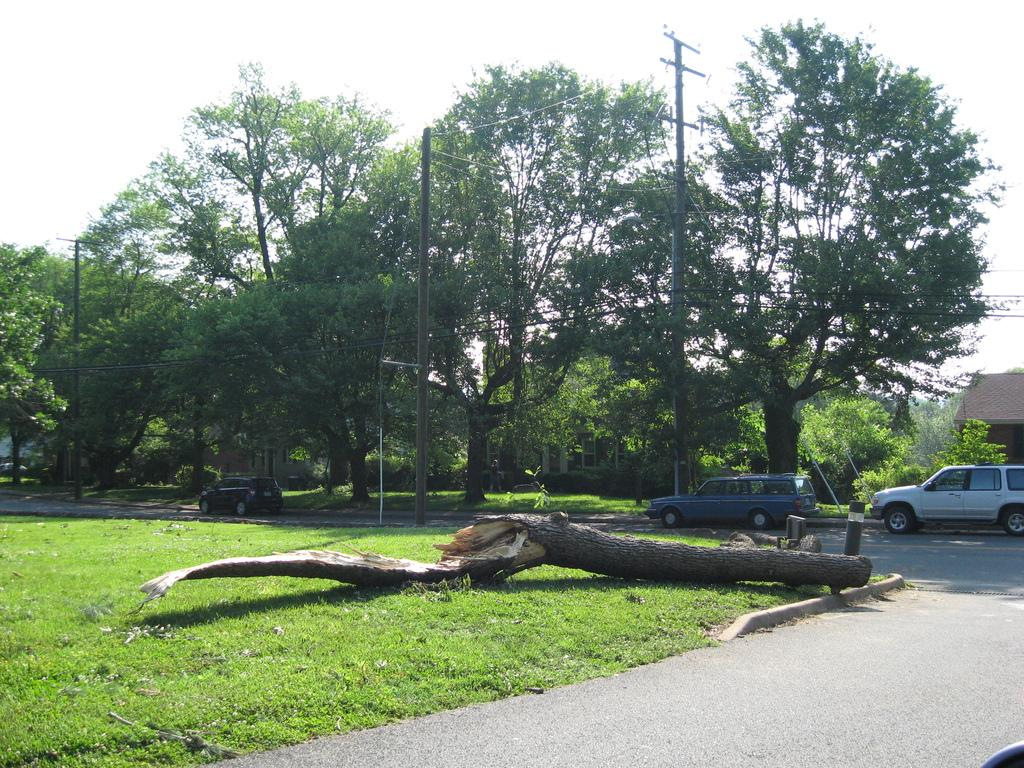What can be seen on the road in the image? There are vehicles on the road in the image. What type of object made of wood can be seen in the image? There is a wooden object in the image. What type of vegetation is present in the image? Grass is present in the image. What other structures can be seen in the image besides the wooden object? There are poles and wires in the image. What can be seen in the background of the image? There are trees, a house, and the sky visible in the background of the image. How does the garden maintain its balance in the image? There is no garden present in the image, so the question of balance does not apply. What type of exchange is taking place between the vehicles and the wooden object in the image? There is no exchange taking place between the vehicles and the wooden object in the image; they are separate entities. 